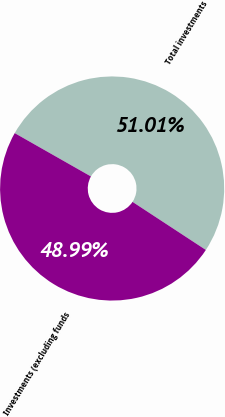<chart> <loc_0><loc_0><loc_500><loc_500><pie_chart><fcel>Total investments<fcel>Investments (excluding funds<nl><fcel>51.01%<fcel>48.99%<nl></chart> 